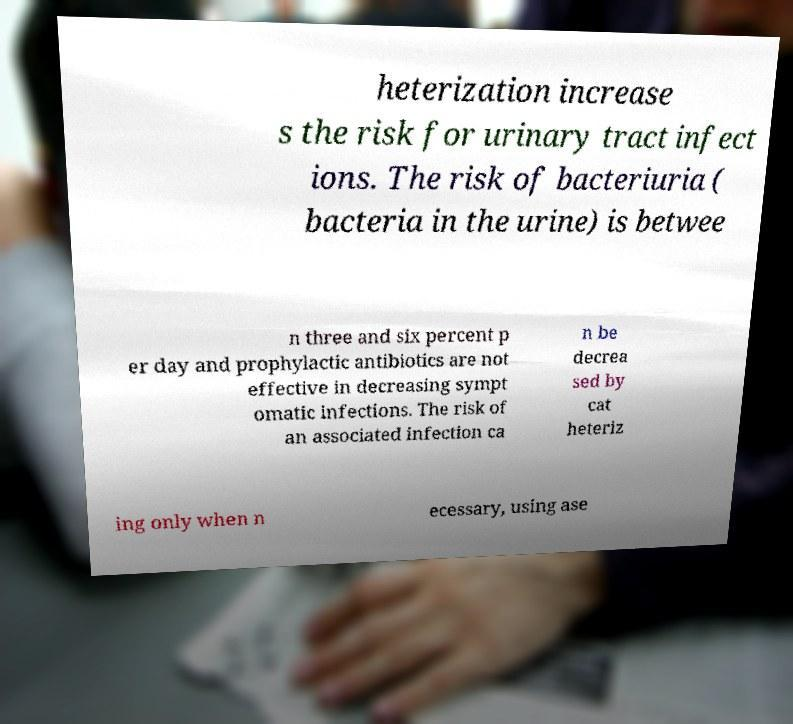Please identify and transcribe the text found in this image. heterization increase s the risk for urinary tract infect ions. The risk of bacteriuria ( bacteria in the urine) is betwee n three and six percent p er day and prophylactic antibiotics are not effective in decreasing sympt omatic infections. The risk of an associated infection ca n be decrea sed by cat heteriz ing only when n ecessary, using ase 